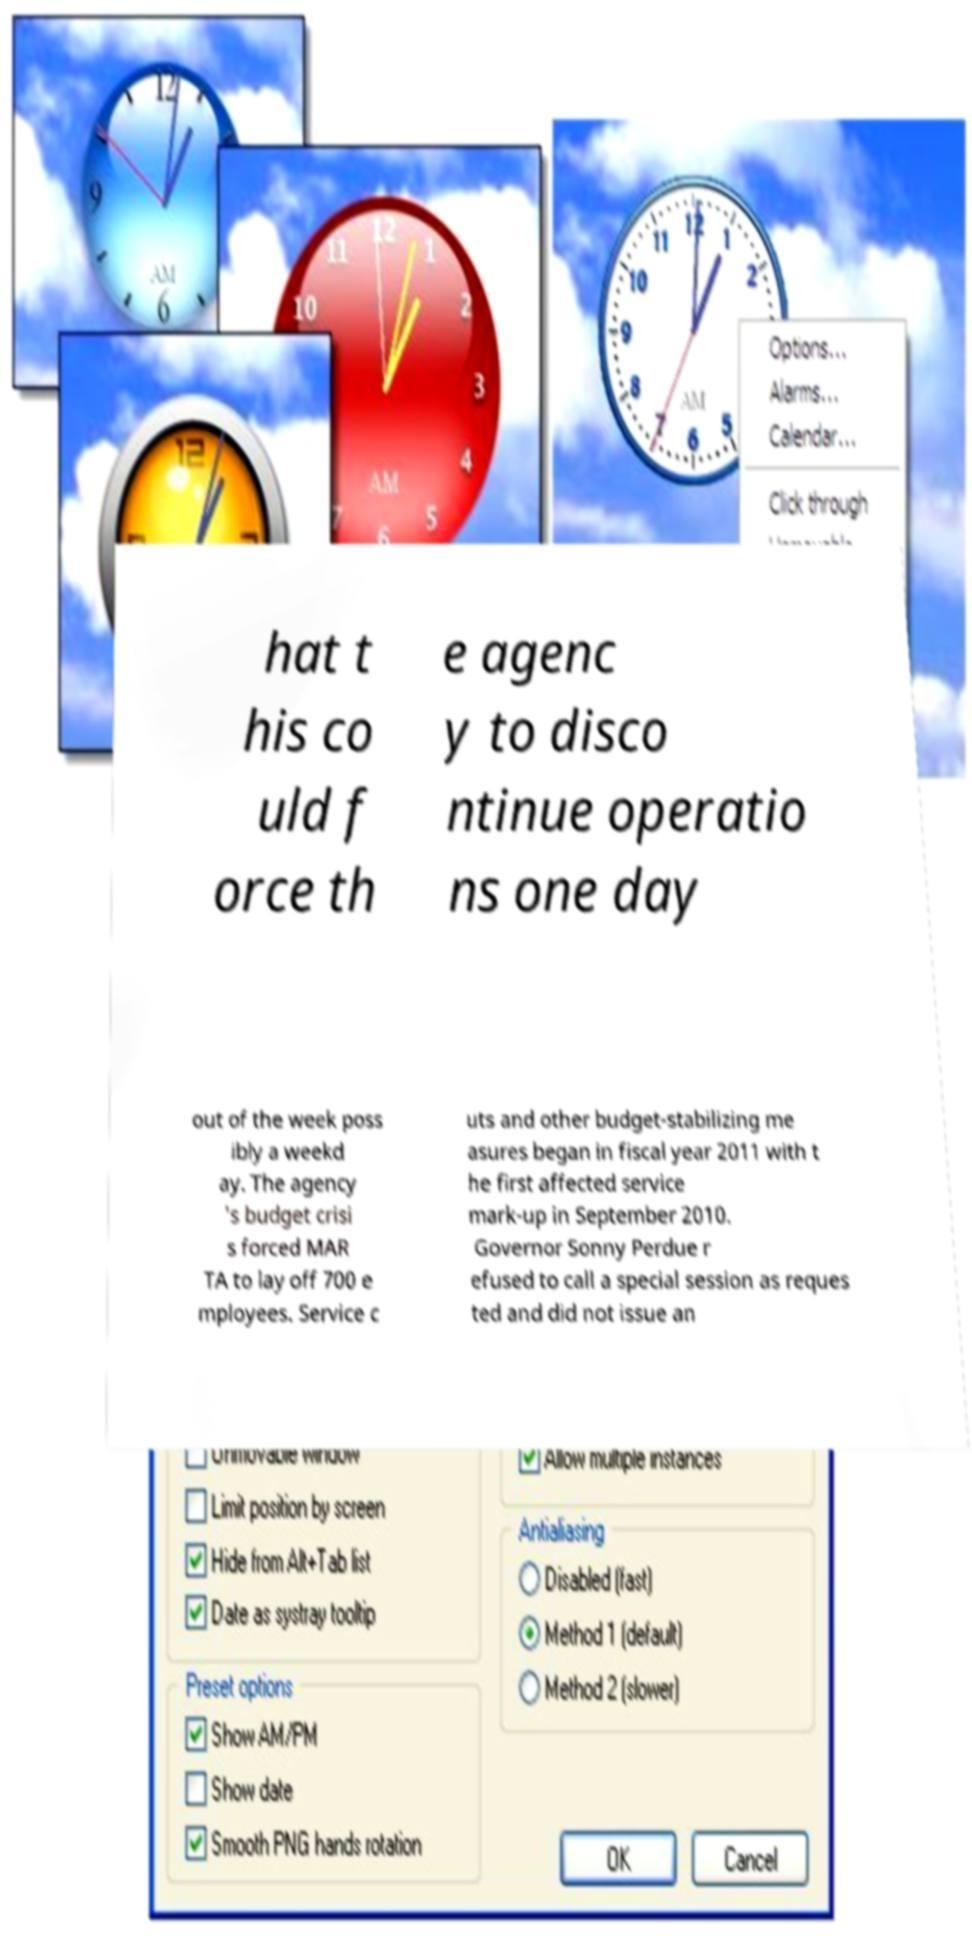What messages or text are displayed in this image? I need them in a readable, typed format. hat t his co uld f orce th e agenc y to disco ntinue operatio ns one day out of the week poss ibly a weekd ay. The agency 's budget crisi s forced MAR TA to lay off 700 e mployees. Service c uts and other budget-stabilizing me asures began in fiscal year 2011 with t he first affected service mark-up in September 2010. Governor Sonny Perdue r efused to call a special session as reques ted and did not issue an 